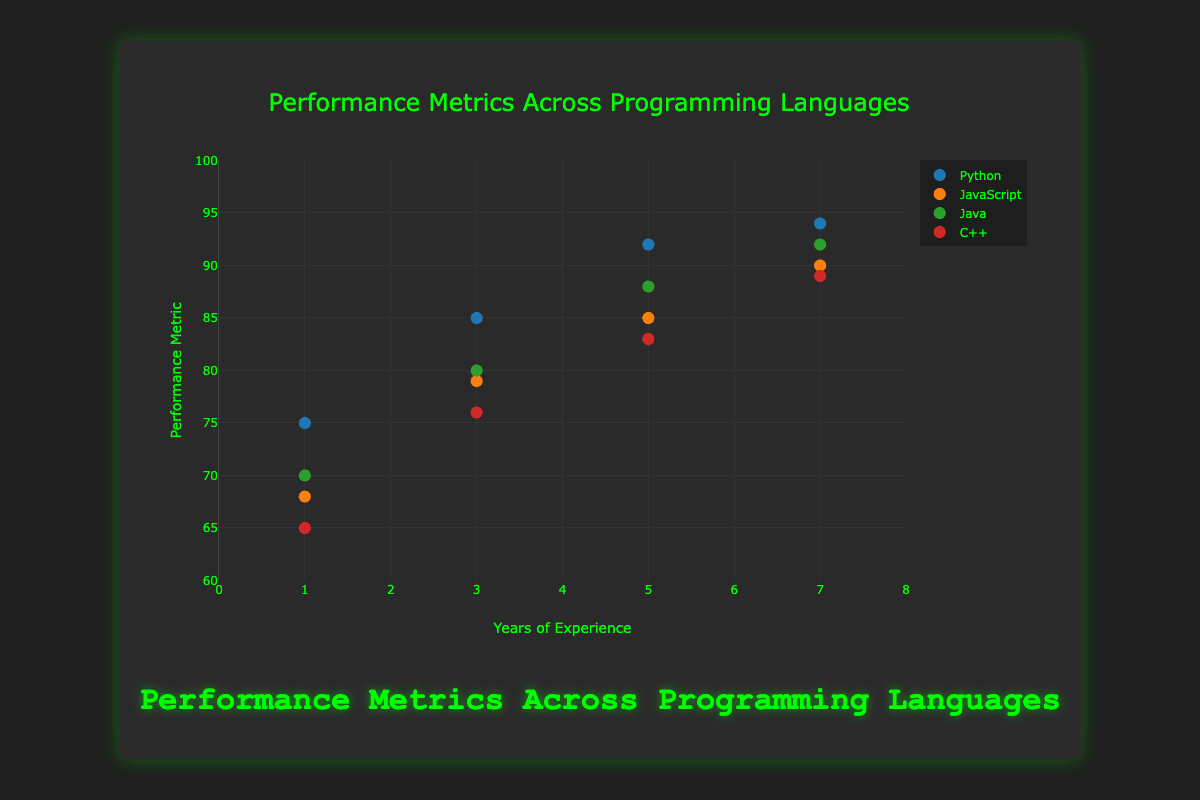What is the title of the figure? The title of the figure is usually found at the top of the plot and describes its overall content or purpose. In this figure, the title reads "Performance Metrics Across Programming Languages."
Answer: Performance Metrics Across Programming Languages How many different programming languages are represented in the figure? By examining the legend or the distinct groupings of data points in the scatter plot, we can see there are four different programming languages: Python, JavaScript, Java, and C++.
Answer: 4 Which programming language has the highest performance metric at 7 years of experience? Locate the data points corresponding to 7 years of experience on the x-axis and identify which programming language's data point has the highest value on the y-axis. For 7 years, Python has the highest performance metric with a value of 94.
Answer: Python Compare the performance metrics of Python and JavaScript at 5 years of experience. Which is higher and by how much? Identify the data points for Python and JavaScript at 5 years of experience on the x-axis. Python's performance metric is 92, while JavaScript's is 85. The difference is 92 - 85 = 7. So, Python's performance is higher by 7.
Answer: Python by 7 What is the average performance metric for C++ at all years of experience? Calculate the average of the C++ performance metrics across all years: (65 + 76 + 83 + 89) / 4. Summing these values gives 313, and dividing by 4 gives 78.25.
Answer: 78.25 Which language shows the least improvement in performance metric from 1 to 7 years of experience? Calculate the difference in performance metrics between 1 and 7 years of experience for each language: Python (94-75=19), JavaScript (90-68=22), Java (92-70=22), C++ (89-65=24). Python shows the smallest improvement of 19.
Answer: Python Is there any language whose performance metric values are never the lowest across all years of experience? Compare the performance metric values at each year of experience to find if any language never has the lowest value. C++ has the lowest values at all individual experience levels. For other languages, they each have at least one value that is not the lowest.
Answer: No What is the range of performance metrics for Java across different years of experience? The range is determined by subtracting the minimum value from the maximum value in the set of performance metrics for Java. Java’s performance metrics range from 70 to 92. Hence, the range is 92 - 70 = 22.
Answer: 22 How does the performance metric of Python progress with increasing years of experience? By looking at the data points for Python, we see the performance metric increases consistently: 75 at 1 year, 85 at 3 years, 92 at 5 years, and 94 at 7 years. This shows a steady increase in performance with experience.
Answer: It increases consistently 